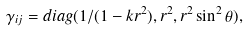Convert formula to latex. <formula><loc_0><loc_0><loc_500><loc_500>\gamma _ { i j } = d i a g ( 1 / ( 1 - k r ^ { 2 } ) , r ^ { 2 } , r ^ { 2 } \sin ^ { 2 } \theta ) ,</formula> 